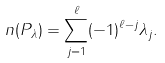Convert formula to latex. <formula><loc_0><loc_0><loc_500><loc_500>n ( P _ { \lambda } ) = \sum _ { j = 1 } ^ { \ell } ( - 1 ) ^ { \ell - j } \lambda _ { j } .</formula> 